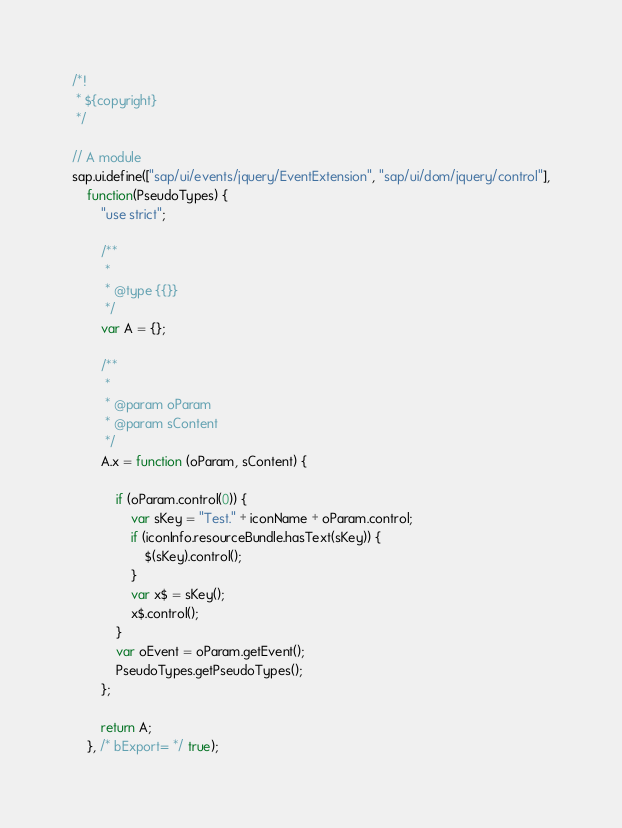Convert code to text. <code><loc_0><loc_0><loc_500><loc_500><_JavaScript_>/*!
 * ${copyright}
 */

// A module
sap.ui.define(["sap/ui/events/jquery/EventExtension", "sap/ui/dom/jquery/control"],
	function(PseudoTypes) {
		"use strict";

		/**
		 *
		 * @type {{}}
		 */
		var A = {};

		/**
		 *
		 * @param oParam
		 * @param sContent
		 */
		A.x = function (oParam, sContent) {

			if (oParam.control(0)) {
				var sKey = "Test." + iconName + oParam.control;
				if (iconInfo.resourceBundle.hasText(sKey)) {
					$(sKey).control();
				}
				var x$ = sKey();
				x$.control();
			}
			var oEvent = oParam.getEvent();
			PseudoTypes.getPseudoTypes();
		};

		return A;
	}, /* bExport= */ true);</code> 